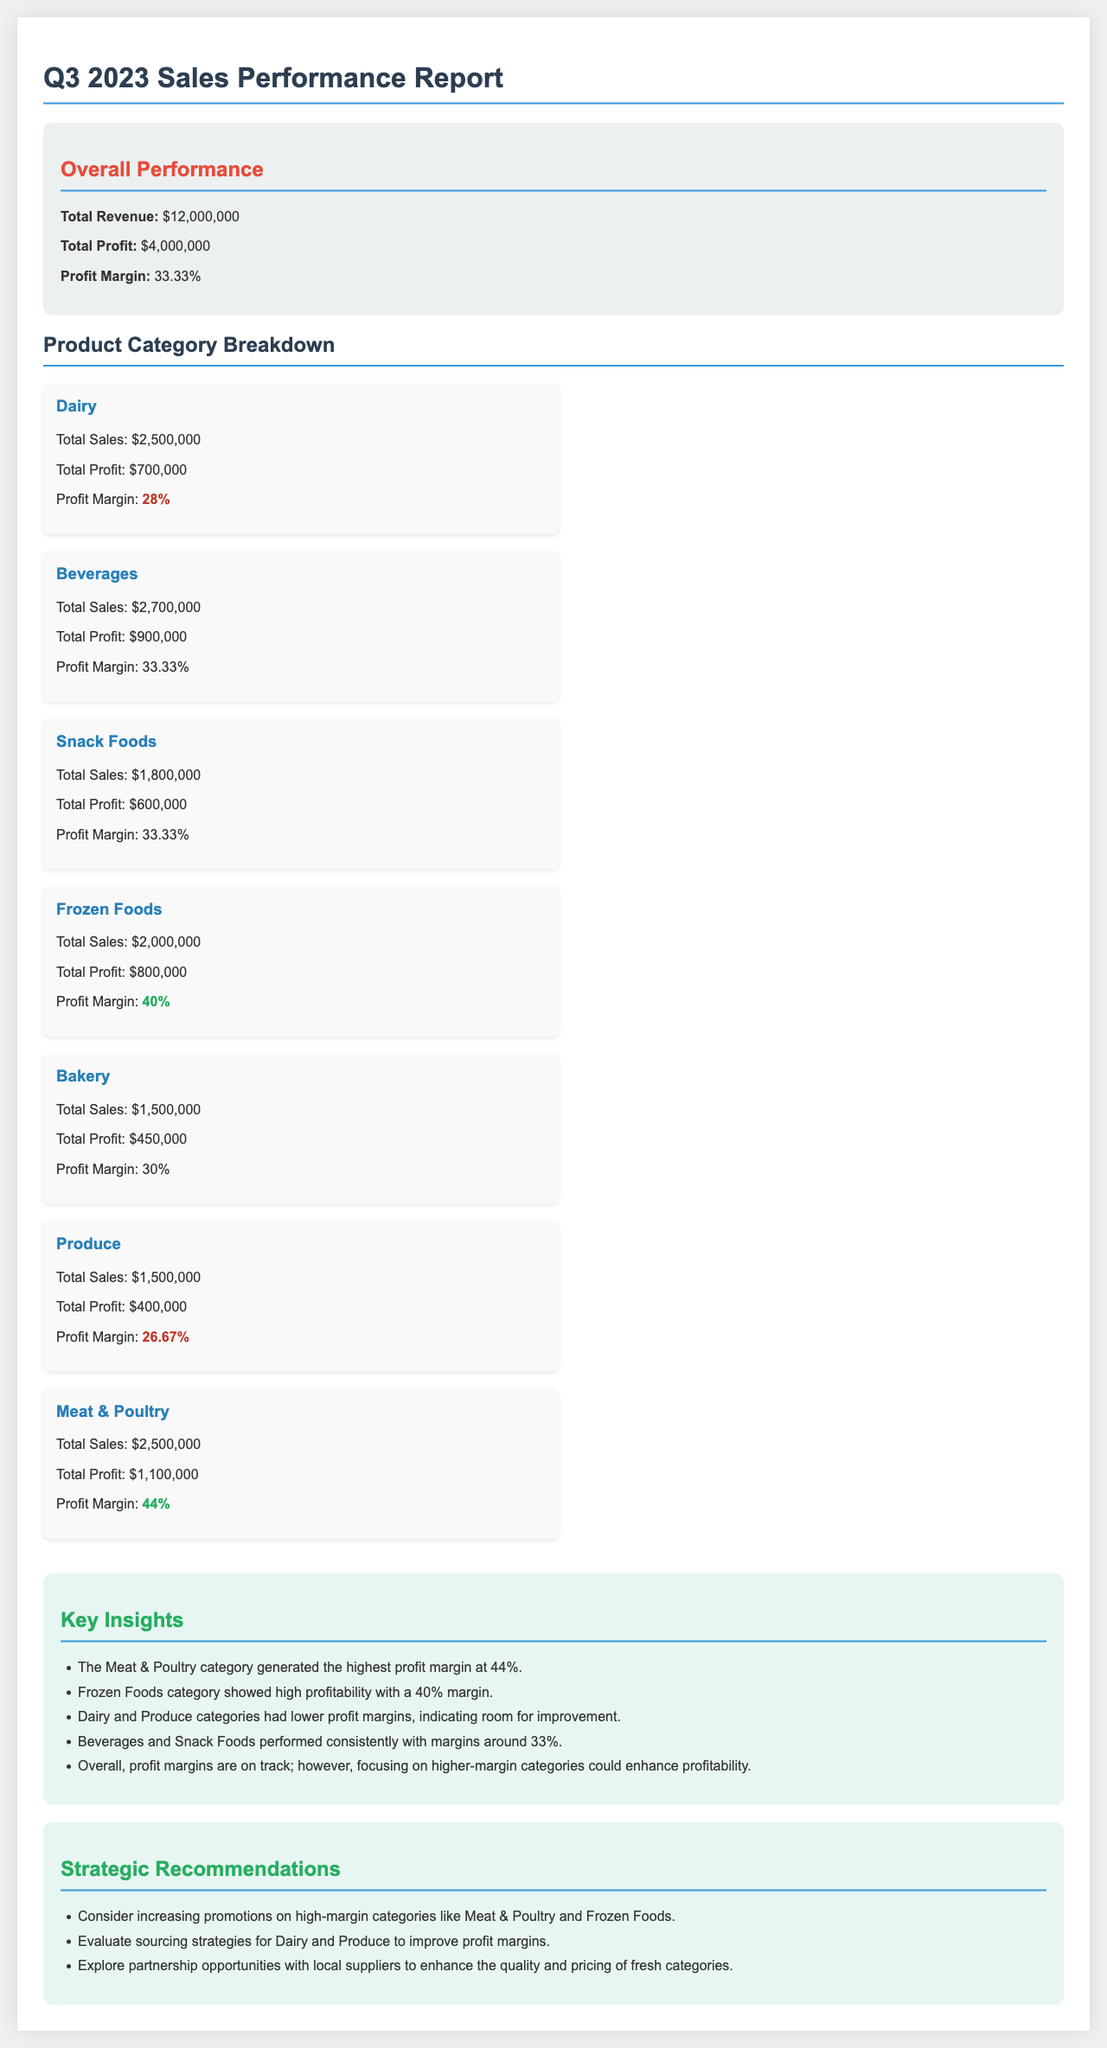What is the total revenue? The total revenue is stated as $12,000,000 in the overall performance section.
Answer: $12,000,000 What is the profit margin for Dairy? The profit margin for Dairy is noted as 28% in the category breakdown section.
Answer: 28% Which product category has the highest profit margin? The document indicates that the Meat & Poultry category has the highest profit margin at 44%.
Answer: 44% What is the total profit for Beverages? The total profit for Beverages is reported as $900,000 in the category breakdown.
Answer: $900,000 Which two categories performed consistently with a margin around 33%? Beverages and Snack Foods categories both show a profit margin of around 33% in the insights section.
Answer: Beverages and Snack Foods What is the total sales for the Frozen Foods category? The total sales for Frozen Foods are listed as $2,000,000 in the document.
Answer: $2,000,000 What recommendation is made regarding Dairy and Produce? The recommendation suggests evaluating sourcing strategies for Dairy and Produce to improve profit margins.
Answer: Evaluate sourcing strategies What is the total profit for Meat & Poultry? The document states that the total profit for Meat & Poultry is $1,100,000.
Answer: $1,100,000 What does the overall profit margin percentage indicate? The profit margin percentage of 33.33% reflects the overall profitability in the report.
Answer: 33.33% 